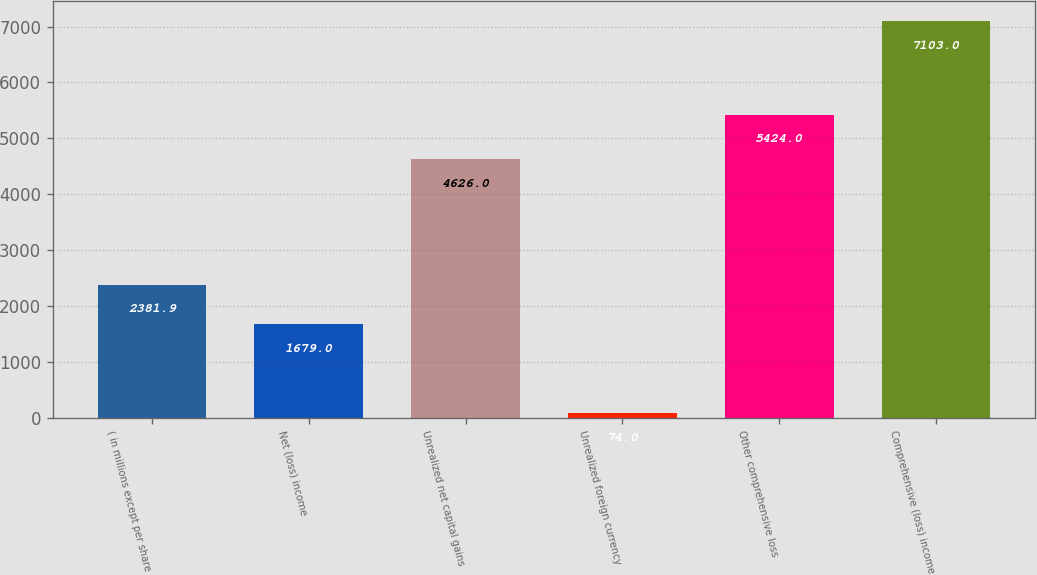<chart> <loc_0><loc_0><loc_500><loc_500><bar_chart><fcel>( in millions except per share<fcel>Net (loss) income<fcel>Unrealized net capital gains<fcel>Unrealized foreign currency<fcel>Other comprehensive loss<fcel>Comprehensive (loss) income<nl><fcel>2381.9<fcel>1679<fcel>4626<fcel>74<fcel>5424<fcel>7103<nl></chart> 